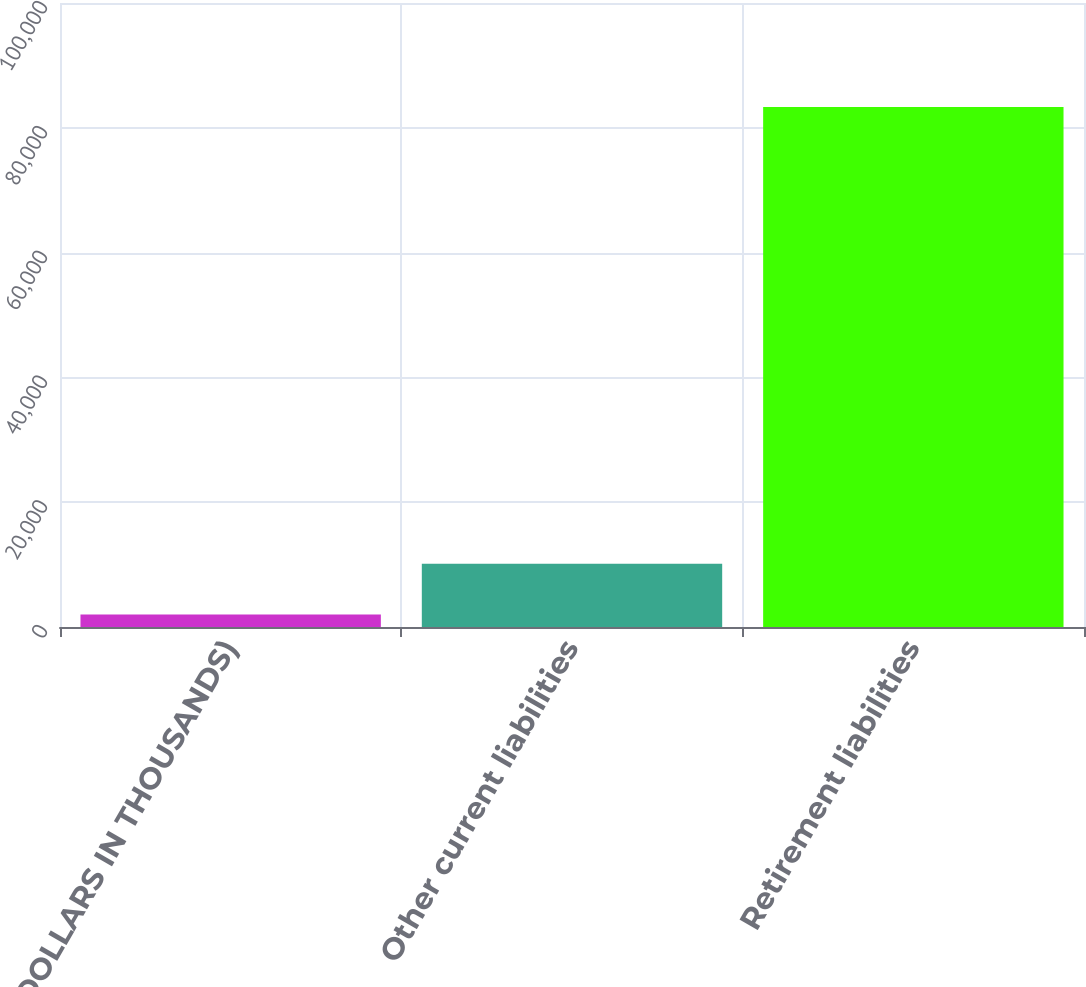Convert chart to OTSL. <chart><loc_0><loc_0><loc_500><loc_500><bar_chart><fcel>(DOLLARS IN THOUSANDS)<fcel>Other current liabilities<fcel>Retirement liabilities<nl><fcel>2015<fcel>10146.9<fcel>83334<nl></chart> 